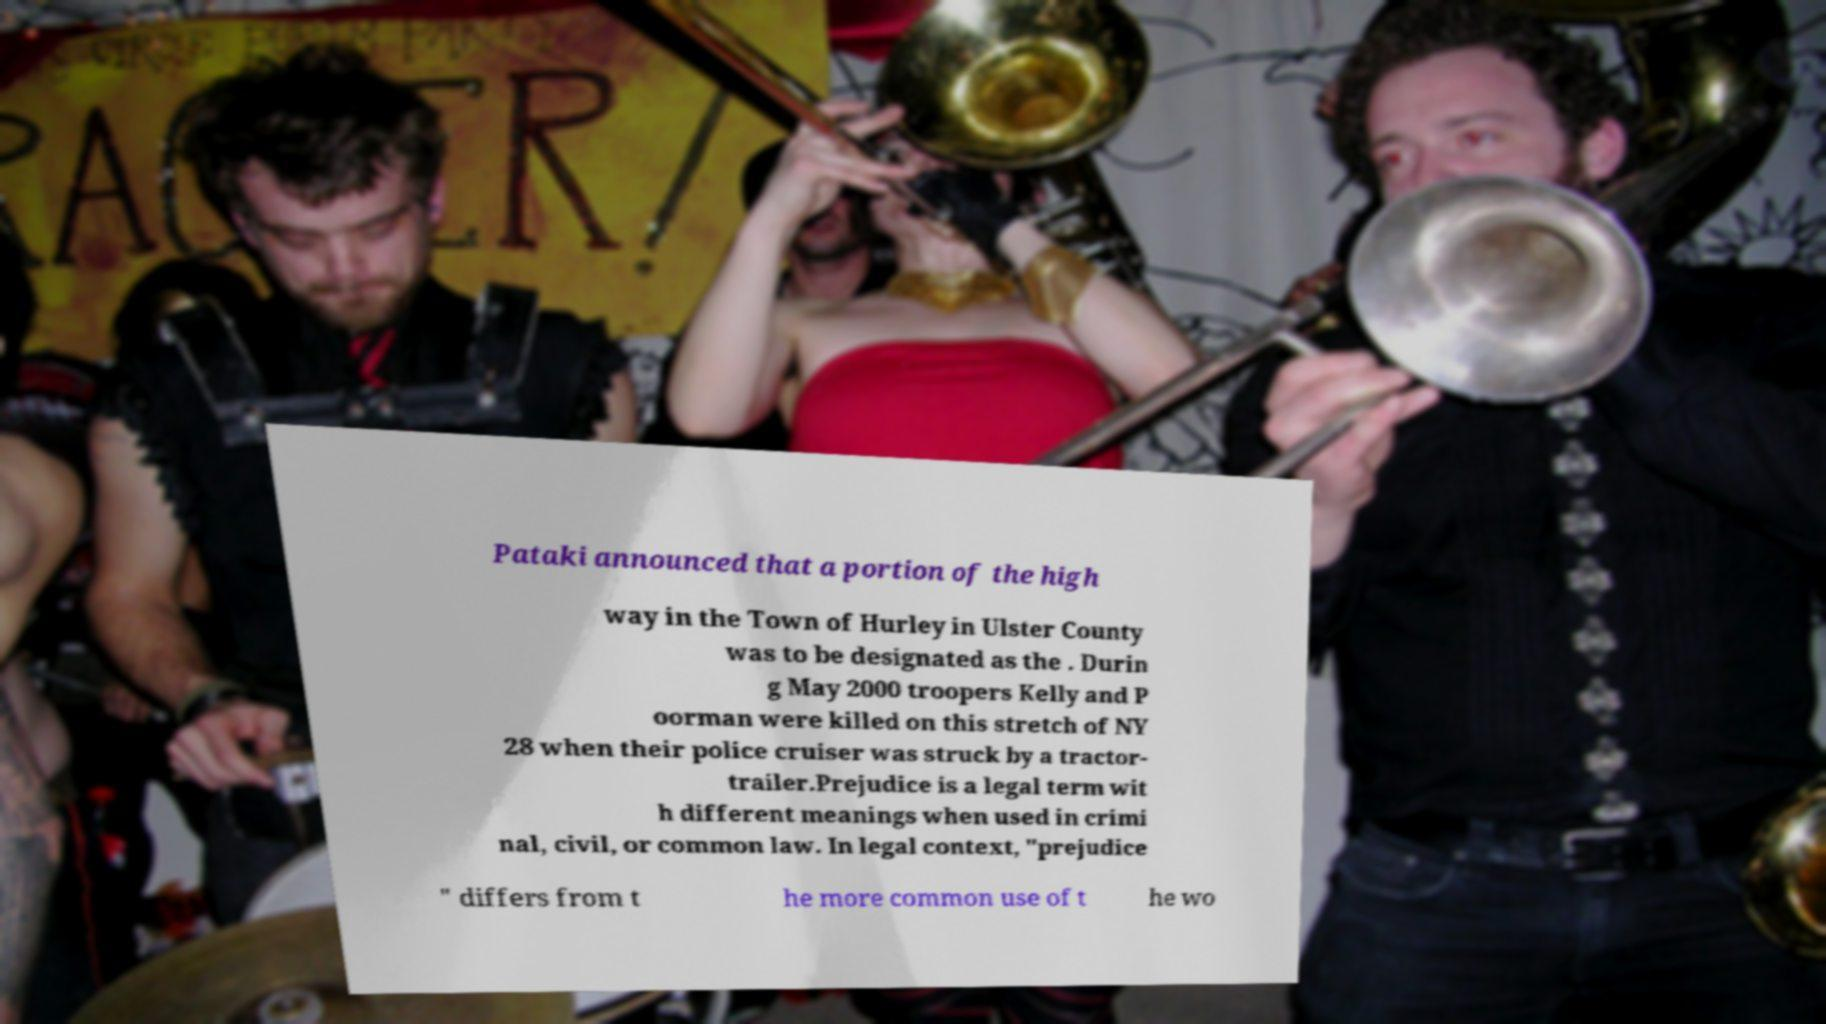Please read and relay the text visible in this image. What does it say? Pataki announced that a portion of the high way in the Town of Hurley in Ulster County was to be designated as the . Durin g May 2000 troopers Kelly and P oorman were killed on this stretch of NY 28 when their police cruiser was struck by a tractor- trailer.Prejudice is a legal term wit h different meanings when used in crimi nal, civil, or common law. In legal context, "prejudice " differs from t he more common use of t he wo 